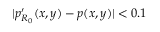<formula> <loc_0><loc_0><loc_500><loc_500>| p _ { R _ { 0 } } ^ { \prime } ( x , y ) - p ( x , y ) | < 0 . 1</formula> 